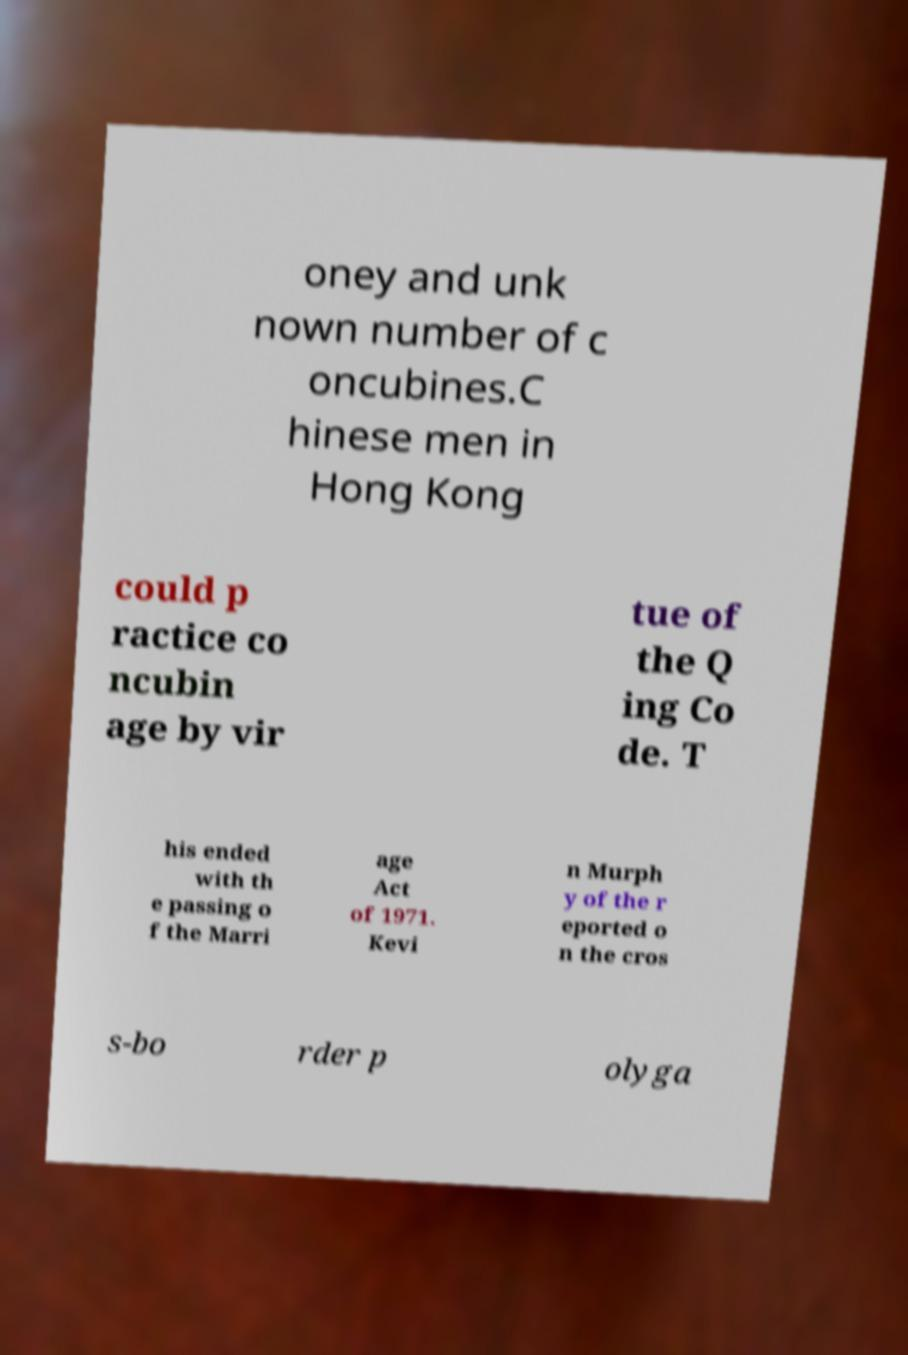There's text embedded in this image that I need extracted. Can you transcribe it verbatim? oney and unk nown number of c oncubines.C hinese men in Hong Kong could p ractice co ncubin age by vir tue of the Q ing Co de. T his ended with th e passing o f the Marri age Act of 1971. Kevi n Murph y of the r eported o n the cros s-bo rder p olyga 